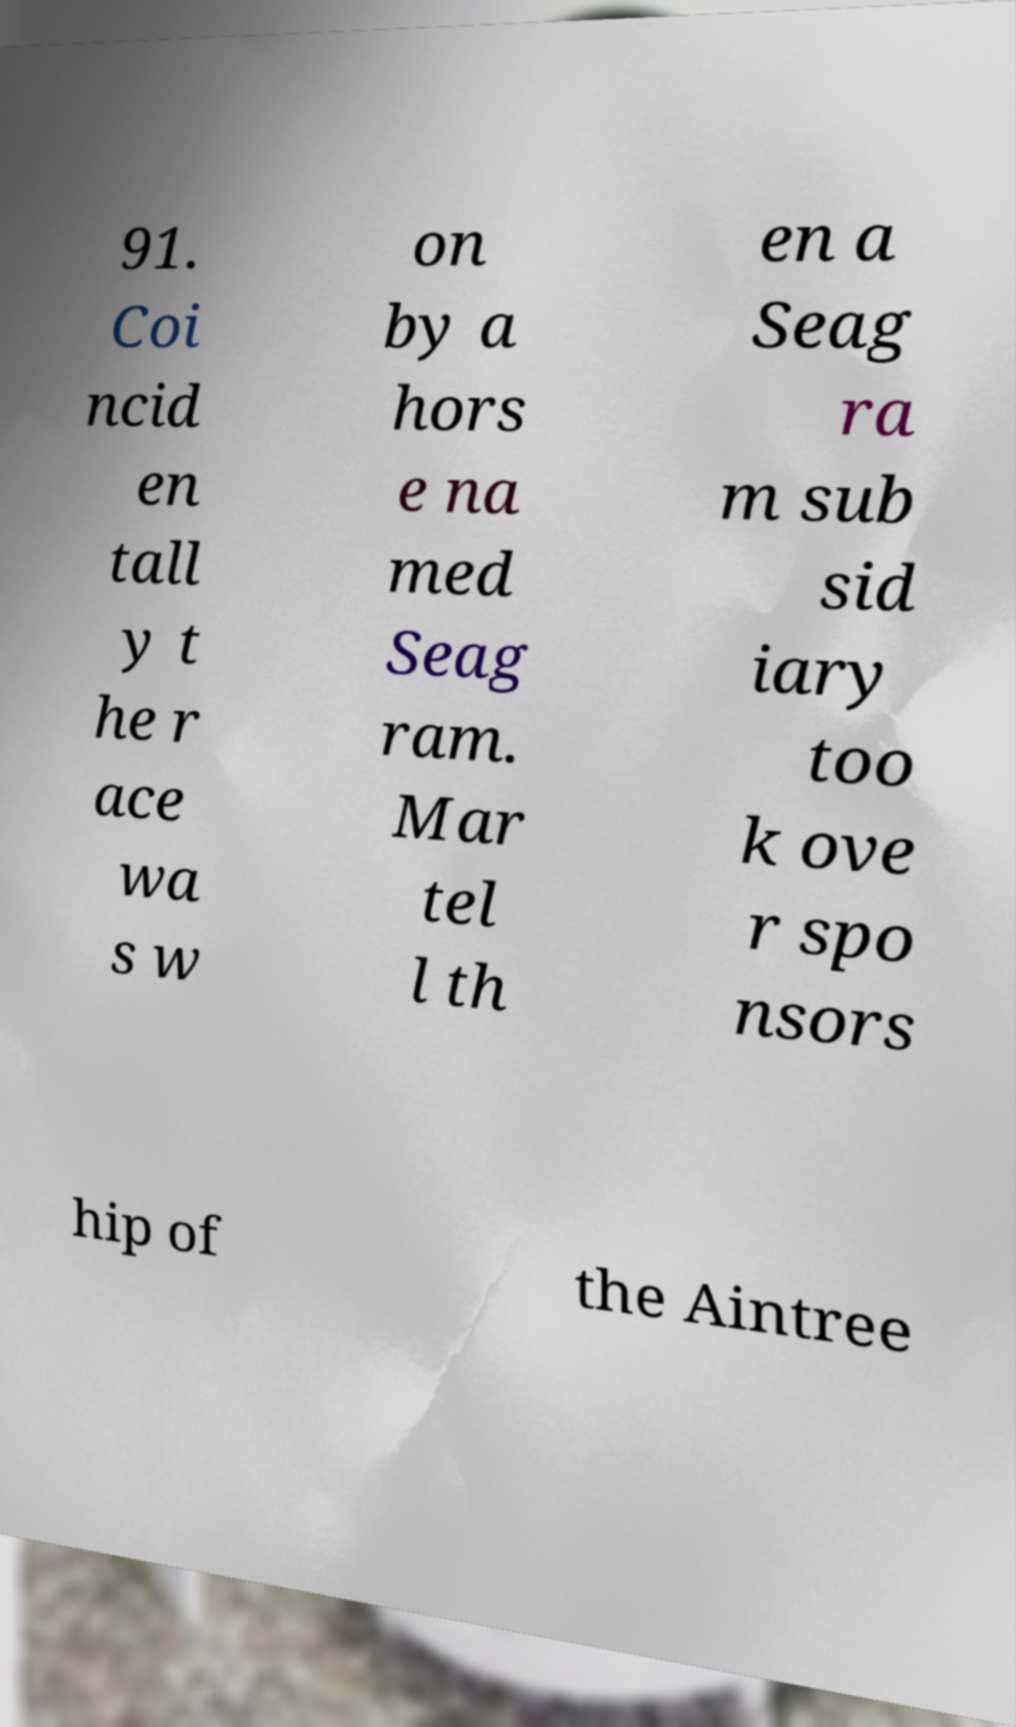What messages or text are displayed in this image? I need them in a readable, typed format. 91. Coi ncid en tall y t he r ace wa s w on by a hors e na med Seag ram. Mar tel l th en a Seag ra m sub sid iary too k ove r spo nsors hip of the Aintree 